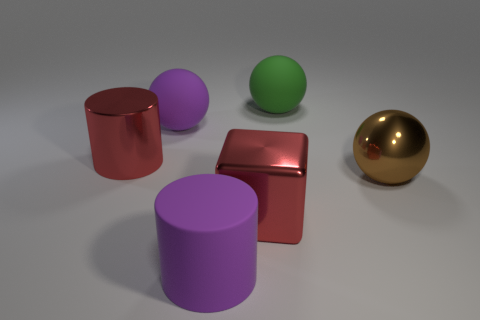Is the color of the metallic cylinder the same as the sphere that is in front of the red cylinder? no 